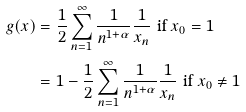Convert formula to latex. <formula><loc_0><loc_0><loc_500><loc_500>g ( x ) & = \frac { 1 } { 2 } \sum _ { n = 1 } ^ { \infty } \frac { 1 } { n ^ { 1 + \alpha } } \frac { 1 } { x _ { n } } \text { if $x_{0}=1$} \\ & = 1 - \frac { 1 } { 2 } \sum _ { n = 1 } ^ { \infty } \frac { 1 } { n ^ { 1 + \alpha } } \frac { 1 } { x _ { n } } \text { if $x_{0}\neq 1$}</formula> 